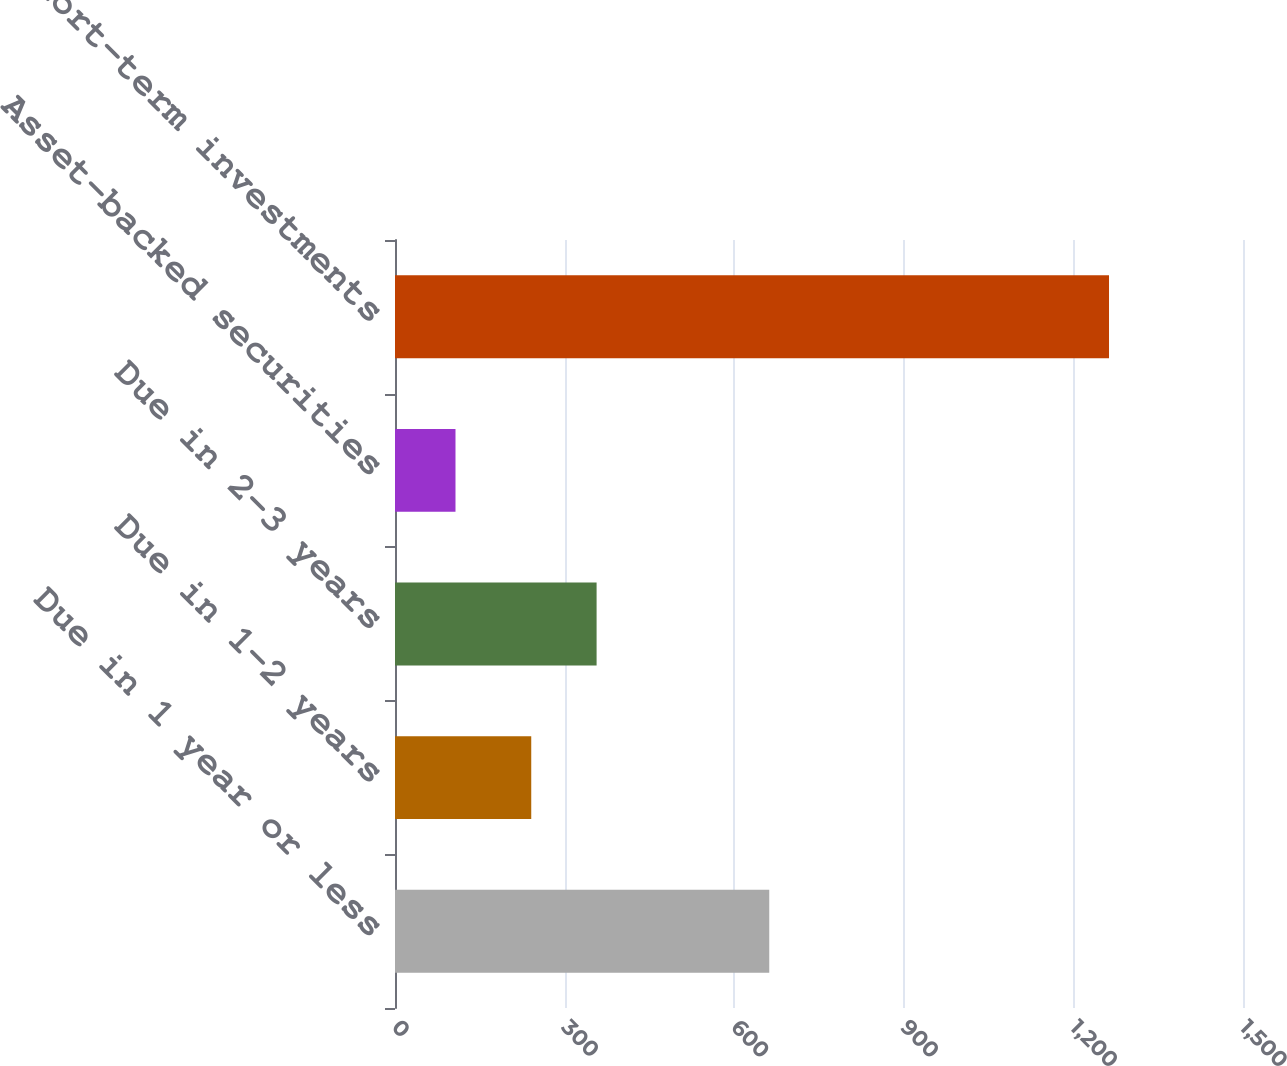<chart> <loc_0><loc_0><loc_500><loc_500><bar_chart><fcel>Due in 1 year or less<fcel>Due in 1-2 years<fcel>Due in 2-3 years<fcel>Asset-backed securities<fcel>Short-term investments<nl><fcel>662<fcel>241<fcel>356.6<fcel>107<fcel>1263<nl></chart> 